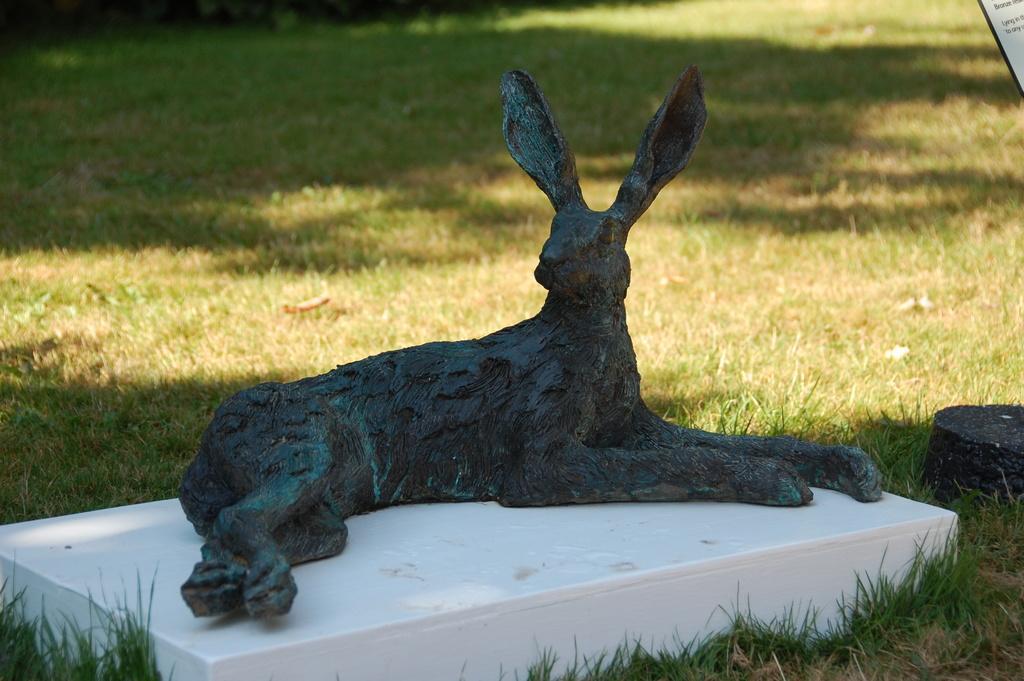In one or two sentences, can you explain what this image depicts? In this image there is a sculpture of an animal on the floor. Around it there's grass on the ground. 